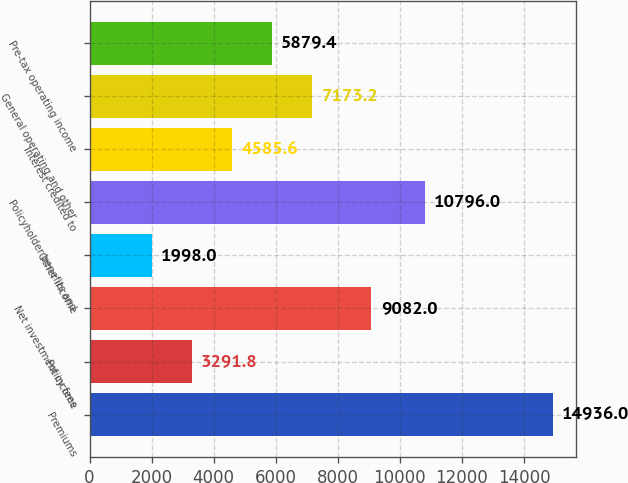Convert chart to OTSL. <chart><loc_0><loc_0><loc_500><loc_500><bar_chart><fcel>Premiums<fcel>Policy fees<fcel>Net investment income<fcel>Other income<fcel>Policyholder benefits and<fcel>Interest credited to<fcel>General operating and other<fcel>Pre-tax operating income<nl><fcel>14936<fcel>3291.8<fcel>9082<fcel>1998<fcel>10796<fcel>4585.6<fcel>7173.2<fcel>5879.4<nl></chart> 